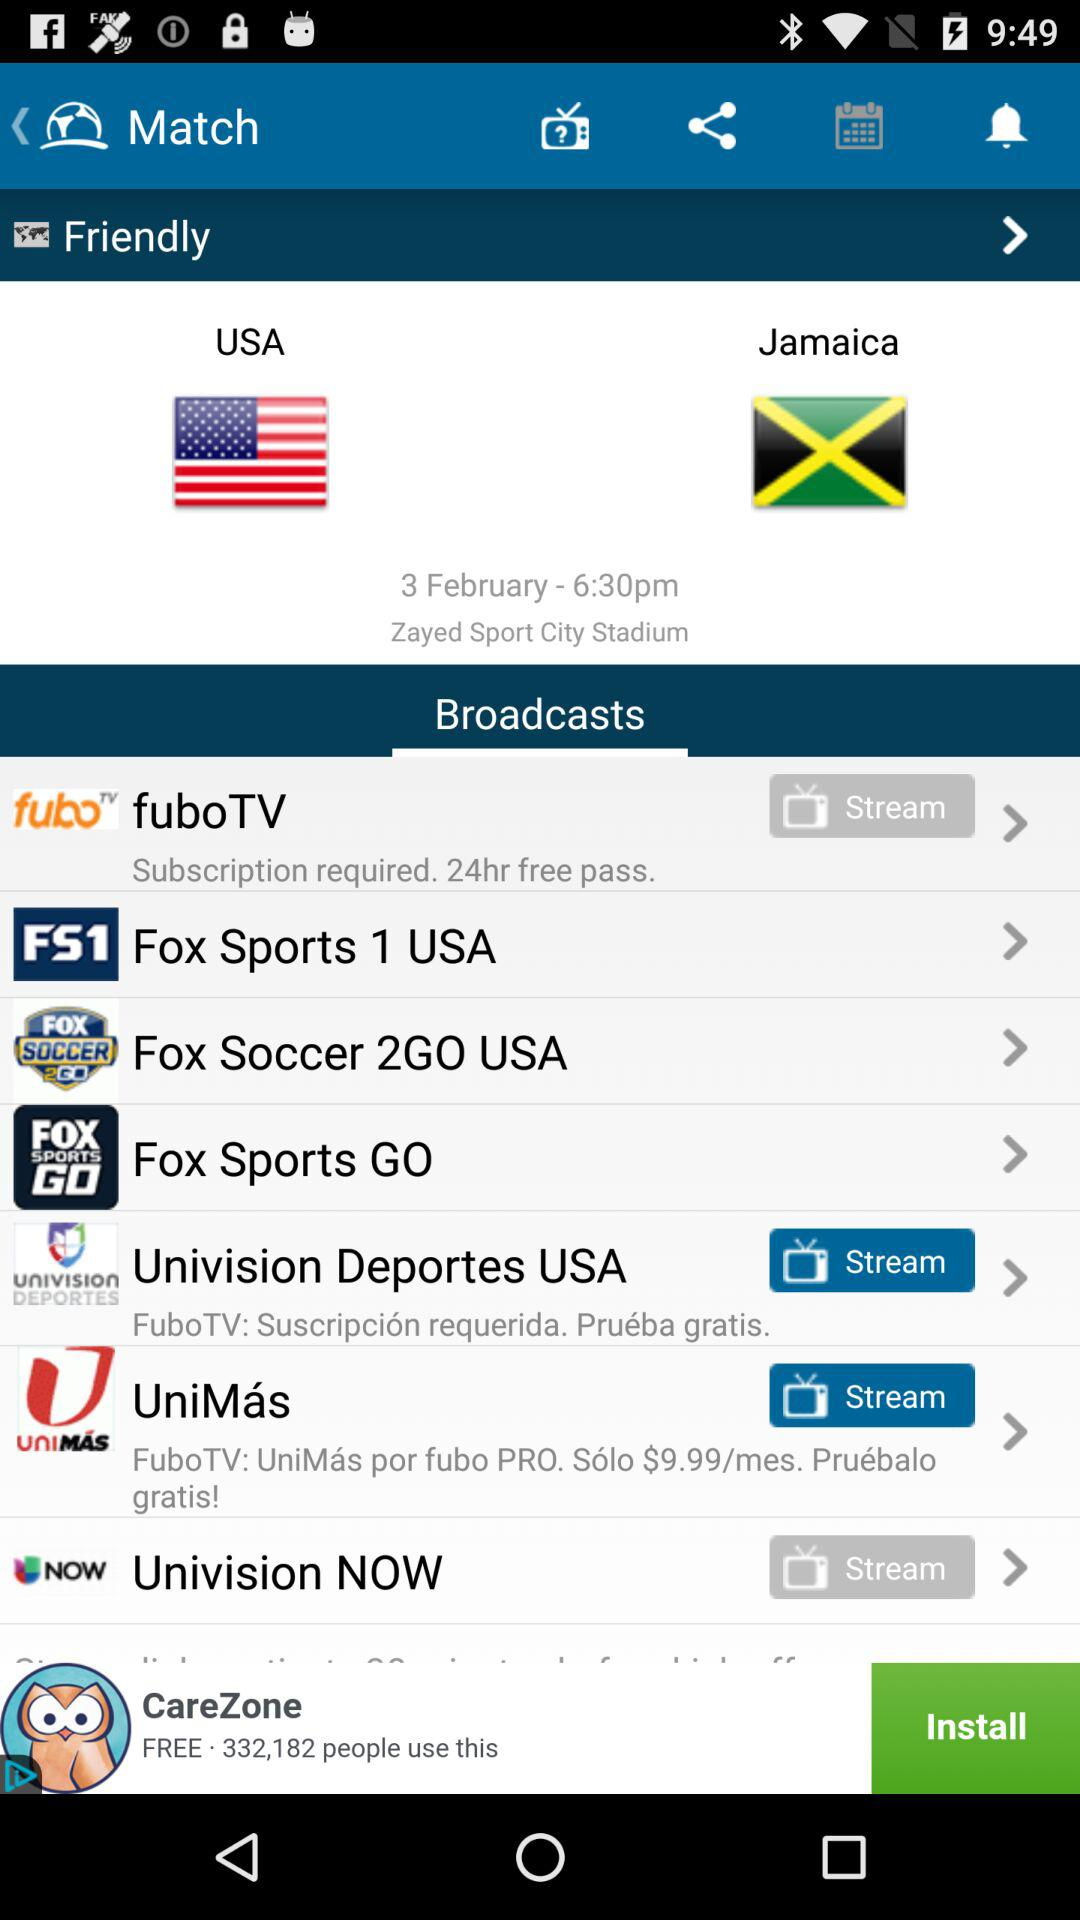What is the location of the match between "USA" and "Jamaica"? The location of the match is Zayed Sports City Stadium. 